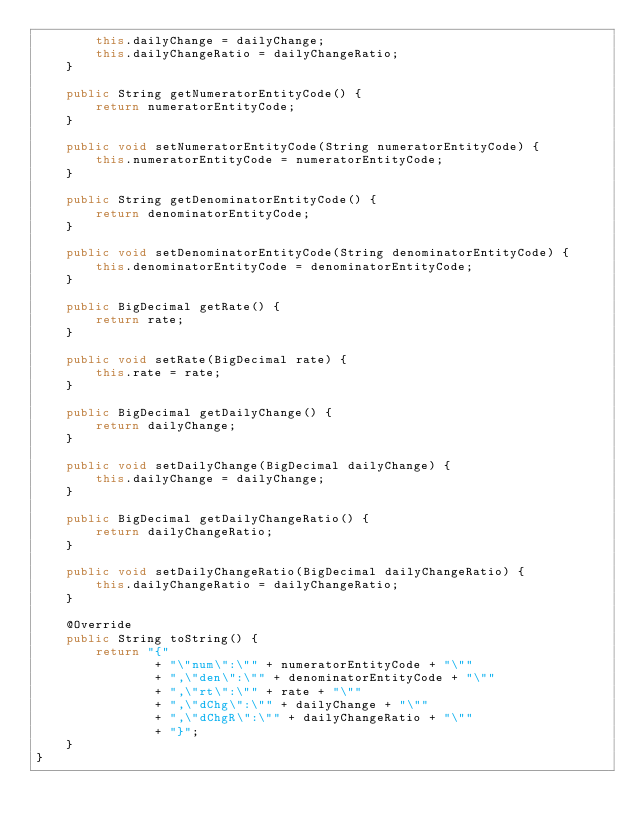<code> <loc_0><loc_0><loc_500><loc_500><_Java_>        this.dailyChange = dailyChange;
        this.dailyChangeRatio = dailyChangeRatio;
    }

    public String getNumeratorEntityCode() {
        return numeratorEntityCode;
    }

    public void setNumeratorEntityCode(String numeratorEntityCode) {
        this.numeratorEntityCode = numeratorEntityCode;
    }

    public String getDenominatorEntityCode() {
        return denominatorEntityCode;
    }

    public void setDenominatorEntityCode(String denominatorEntityCode) {
        this.denominatorEntityCode = denominatorEntityCode;
    }

    public BigDecimal getRate() {
        return rate;
    }

    public void setRate(BigDecimal rate) {
        this.rate = rate;
    }

    public BigDecimal getDailyChange() {
        return dailyChange;
    }

    public void setDailyChange(BigDecimal dailyChange) {
        this.dailyChange = dailyChange;
    }

    public BigDecimal getDailyChangeRatio() {
        return dailyChangeRatio;
    }

    public void setDailyChangeRatio(BigDecimal dailyChangeRatio) {
        this.dailyChangeRatio = dailyChangeRatio;
    }

    @Override
    public String toString() {
        return "{"
                + "\"num\":\"" + numeratorEntityCode + "\""
                + ",\"den\":\"" + denominatorEntityCode + "\""
                + ",\"rt\":\"" + rate + "\""
                + ",\"dChg\":\"" + dailyChange + "\""
                + ",\"dChgR\":\"" + dailyChangeRatio + "\""
                + "}";
    }
}
</code> 